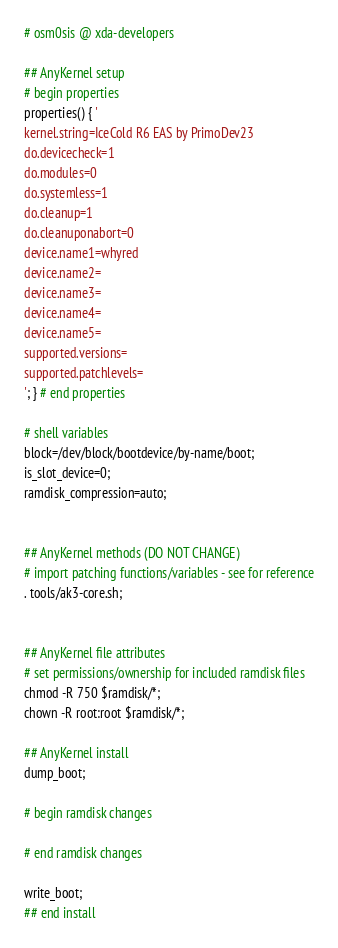Convert code to text. <code><loc_0><loc_0><loc_500><loc_500><_Bash_># osm0sis @ xda-developers

## AnyKernel setup
# begin properties
properties() { '
kernel.string=IceCold R6 EAS by PrimoDev23
do.devicecheck=1
do.modules=0
do.systemless=1
do.cleanup=1
do.cleanuponabort=0
device.name1=whyred
device.name2=
device.name3=
device.name4=
device.name5=
supported.versions=
supported.patchlevels=
'; } # end properties

# shell variables
block=/dev/block/bootdevice/by-name/boot;
is_slot_device=0;
ramdisk_compression=auto;


## AnyKernel methods (DO NOT CHANGE)
# import patching functions/variables - see for reference
. tools/ak3-core.sh;


## AnyKernel file attributes
# set permissions/ownership for included ramdisk files
chmod -R 750 $ramdisk/*;
chown -R root:root $ramdisk/*;

## AnyKernel install
dump_boot;

# begin ramdisk changes

# end ramdisk changes

write_boot;
## end install

</code> 